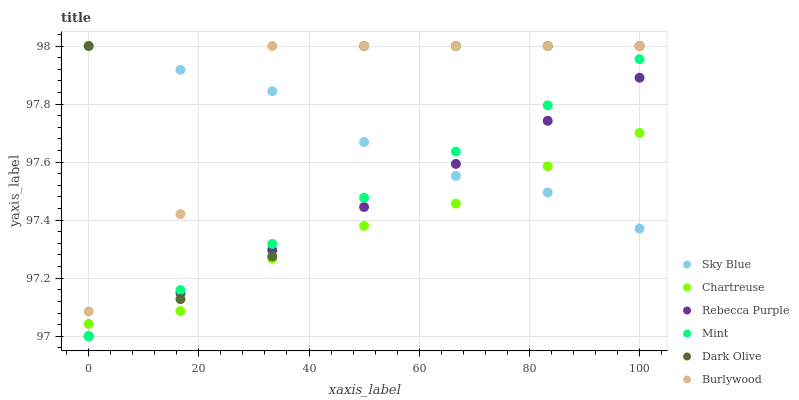Does Chartreuse have the minimum area under the curve?
Answer yes or no. Yes. Does Burlywood have the maximum area under the curve?
Answer yes or no. Yes. Does Dark Olive have the minimum area under the curve?
Answer yes or no. No. Does Dark Olive have the maximum area under the curve?
Answer yes or no. No. Is Mint the smoothest?
Answer yes or no. Yes. Is Dark Olive the roughest?
Answer yes or no. Yes. Is Chartreuse the smoothest?
Answer yes or no. No. Is Chartreuse the roughest?
Answer yes or no. No. Does Rebecca Purple have the lowest value?
Answer yes or no. Yes. Does Dark Olive have the lowest value?
Answer yes or no. No. Does Sky Blue have the highest value?
Answer yes or no. Yes. Does Chartreuse have the highest value?
Answer yes or no. No. Is Mint less than Burlywood?
Answer yes or no. Yes. Is Burlywood greater than Rebecca Purple?
Answer yes or no. Yes. Does Dark Olive intersect Burlywood?
Answer yes or no. Yes. Is Dark Olive less than Burlywood?
Answer yes or no. No. Is Dark Olive greater than Burlywood?
Answer yes or no. No. Does Mint intersect Burlywood?
Answer yes or no. No. 